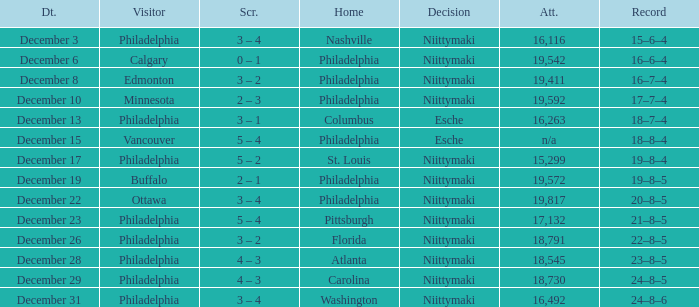What was the decision when the attendance was 19,592? Niittymaki. 